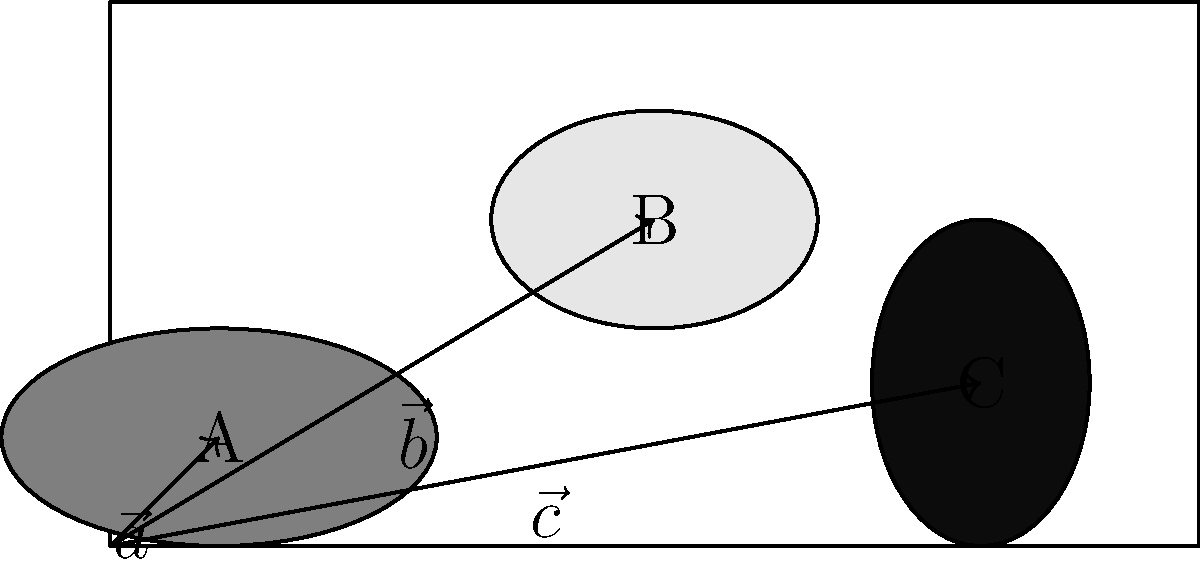You are loading cargo onto a ferry deck. Three items A, B, and C are represented by vectors $\vec{a} = (1, 1)$, $\vec{b} = (5, 3)$, and $\vec{c} = (8, 1.5)$ respectively, where the components indicate their positions on the deck in meters from the origin. To ensure even weight distribution, you need to find the center of mass of these items. Calculate the magnitude of the vector representing the center of mass, assuming all items have equal weight. To find the center of mass of equally weighted objects, we can follow these steps:

1) First, we need to calculate the average of the x and y components separately.

2) For the x-component:
   $x_{avg} = \frac{x_a + x_b + x_c}{3} = \frac{1 + 5 + 8}{3} = \frac{14}{3}$

3) For the y-component:
   $y_{avg} = \frac{y_a + y_b + y_c}{3} = \frac{1 + 3 + 1.5}{3} = \frac{5.5}{3}$

4) The center of mass is represented by the vector:
   $\vec{CM} = (\frac{14}{3}, \frac{5.5}{3})$

5) To find the magnitude of this vector, we use the Pythagorean theorem:
   $|\vec{CM}| = \sqrt{(\frac{14}{3})^2 + (\frac{5.5}{3})^2}$

6) Simplifying:
   $|\vec{CM}| = \sqrt{\frac{196}{9} + \frac{30.25}{9}} = \sqrt{\frac{226.25}{9}} = \frac{\sqrt{226.25}}{3}$

7) This simplifies to:
   $|\vec{CM}| = \frac{\sqrt{226.25}}{3} \approx 5.01$ meters

Therefore, the magnitude of the vector representing the center of mass is approximately 5.01 meters from the origin.
Answer: $\frac{\sqrt{226.25}}{3}$ meters 